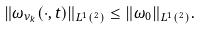<formula> <loc_0><loc_0><loc_500><loc_500>\| \omega _ { \nu _ { k } } ( \cdot , t ) \| _ { L ^ { 1 } ( \real ^ { 2 } ) } \leq \| \omega _ { 0 } \| _ { L ^ { 1 } ( \real ^ { 2 } ) } .</formula> 